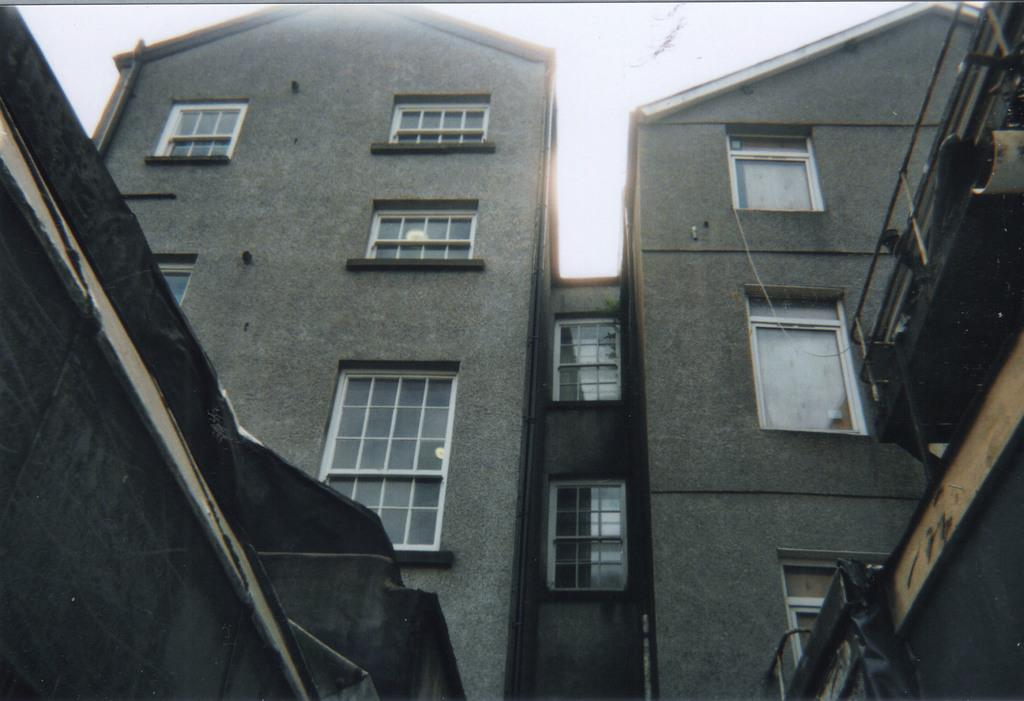What type of structures can be seen in the image? There are buildings in the image. Can you see any cemeteries in the image? There is no mention of a cemetery in the provided fact, and therefore it cannot be determined if one is present in the image. 